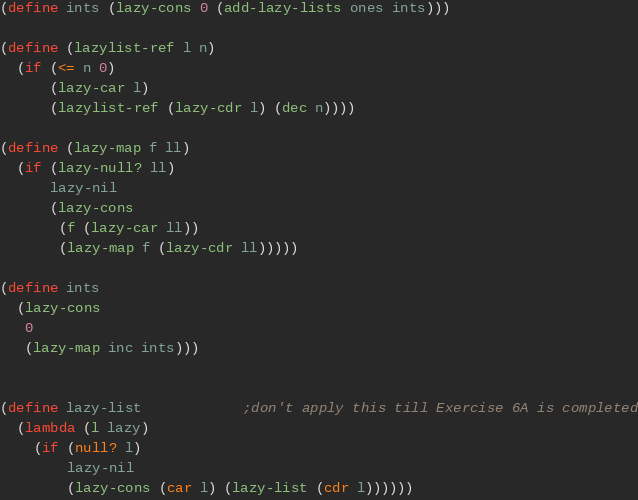<code> <loc_0><loc_0><loc_500><loc_500><_Scheme_>(define ints (lazy-cons 0 (add-lazy-lists ones ints)))

(define (lazylist-ref l n)
  (if (<= n 0)
      (lazy-car l)
      (lazylist-ref (lazy-cdr l) (dec n))))

(define (lazy-map f ll)
  (if (lazy-null? ll)
      lazy-nil
      (lazy-cons
       (f (lazy-car ll))
       (lazy-map f (lazy-cdr ll)))))

(define ints
  (lazy-cons
   0
   (lazy-map inc ints)))


(define lazy-list            ;don't apply this till Exercise 6A is completed
  (lambda (l lazy)
    (if (null? l)
        lazy-nil
        (lazy-cons (car l) (lazy-list (cdr l))))))</code> 